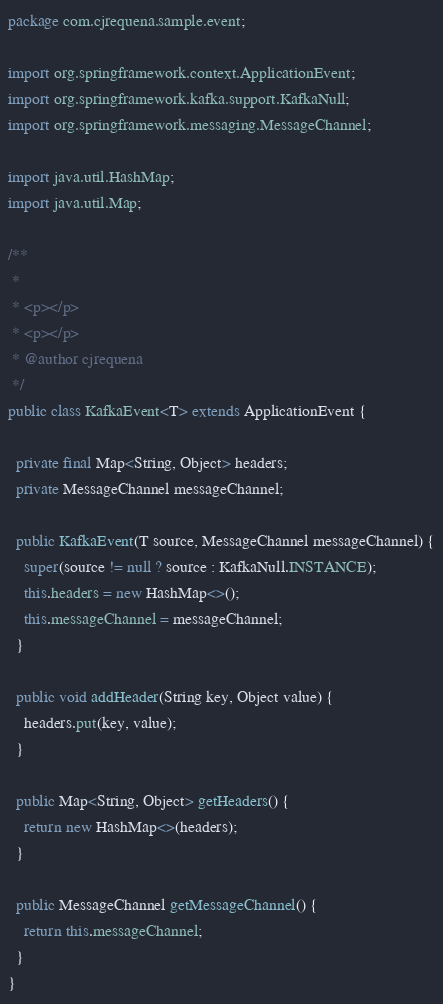<code> <loc_0><loc_0><loc_500><loc_500><_Java_>package com.cjrequena.sample.event;

import org.springframework.context.ApplicationEvent;
import org.springframework.kafka.support.KafkaNull;
import org.springframework.messaging.MessageChannel;

import java.util.HashMap;
import java.util.Map;

/**
 *
 * <p></p>
 * <p></p>
 * @author cjrequena
 */
public class KafkaEvent<T> extends ApplicationEvent {

  private final Map<String, Object> headers;
  private MessageChannel messageChannel;

  public KafkaEvent(T source, MessageChannel messageChannel) {
    super(source != null ? source : KafkaNull.INSTANCE);
    this.headers = new HashMap<>();
    this.messageChannel = messageChannel;
  }

  public void addHeader(String key, Object value) {
    headers.put(key, value);
  }

  public Map<String, Object> getHeaders() {
    return new HashMap<>(headers);
  }

  public MessageChannel getMessageChannel() {
    return this.messageChannel;
  }
}
</code> 